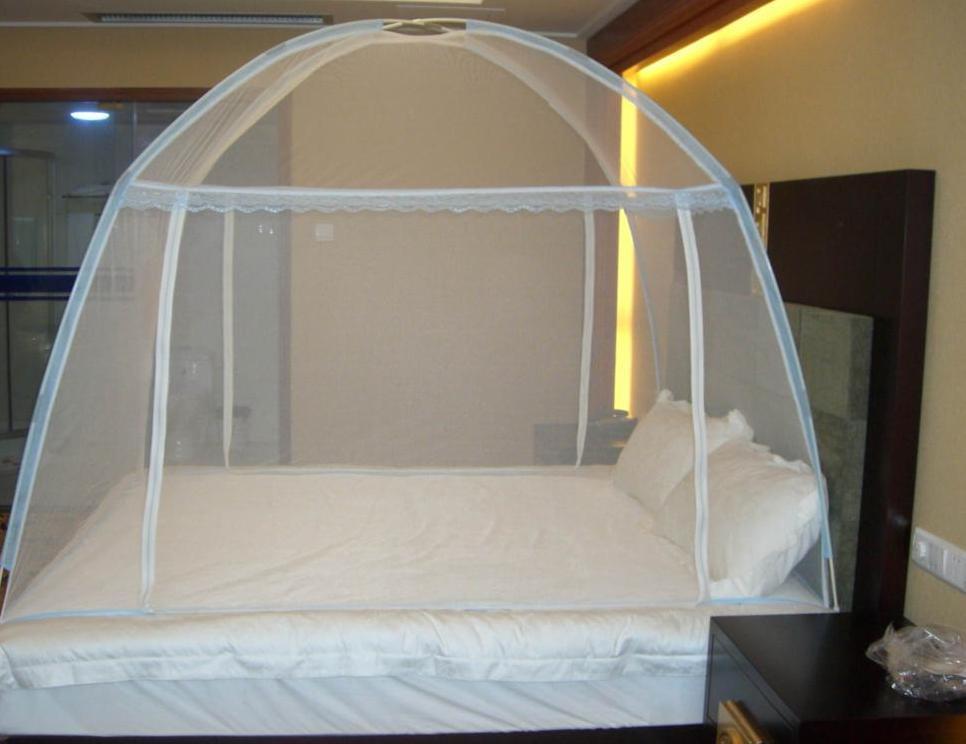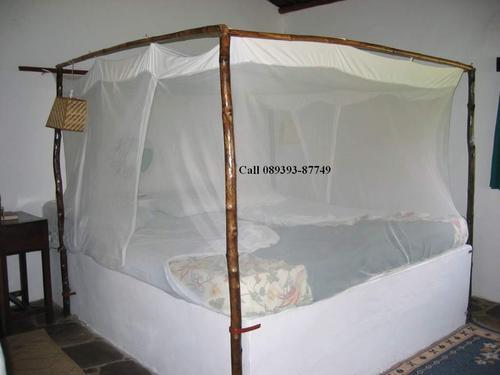The first image is the image on the left, the second image is the image on the right. Analyze the images presented: Is the assertion "There is a round tent and a square tent." valid? Answer yes or no. Yes. 